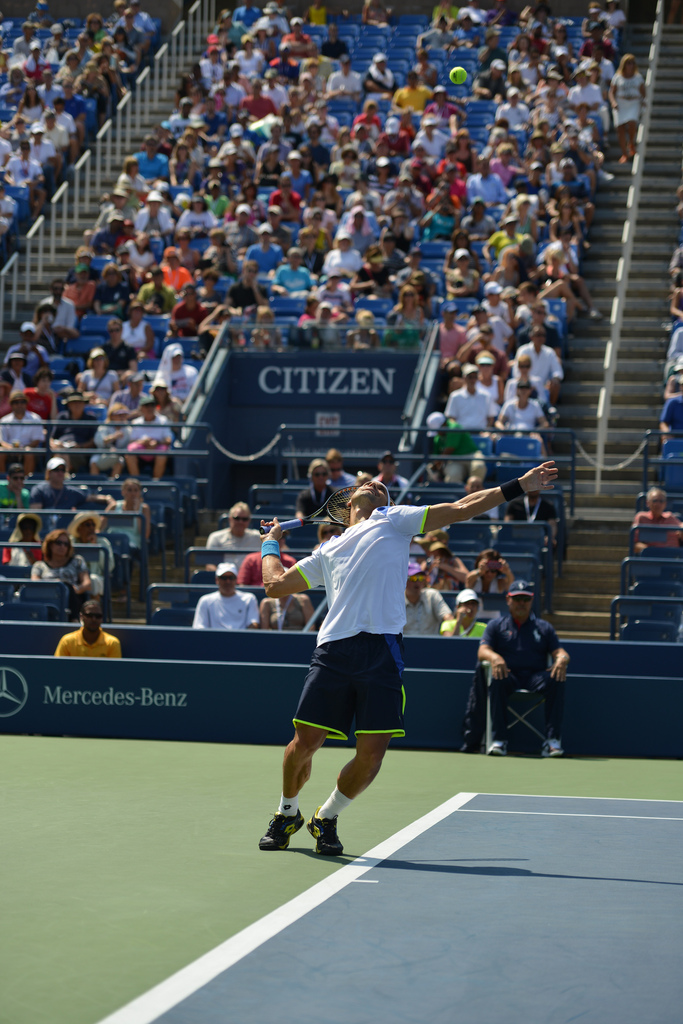Please provide the bounding box coordinate of the region this sentence describes: a person wearing a white shirt and baseball cap. The bounding box coordinates for the person dressed in a white shirt and wearing a baseball cap are [0.35, 0.55, 0.42, 0.61]. This area highlights the upper midsection of the player, capturing both the shirt and cap effectively during the match. 